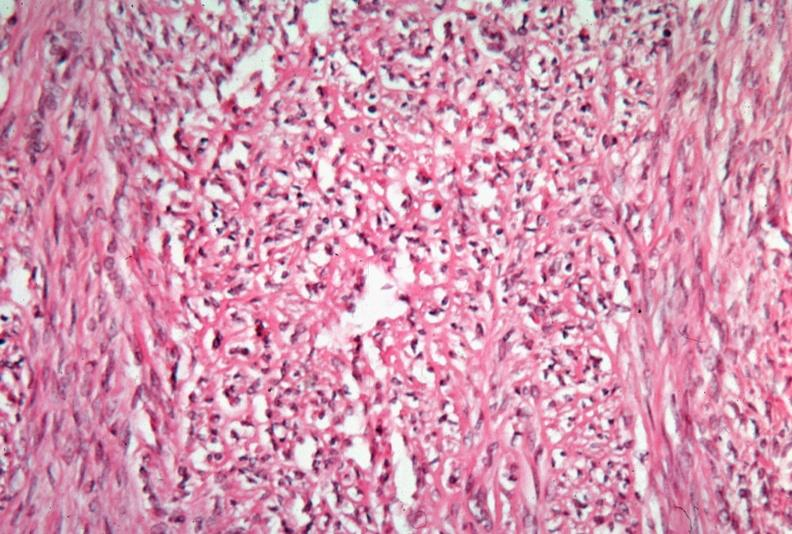what does this image show?
Answer the question using a single word or phrase. Uterus 